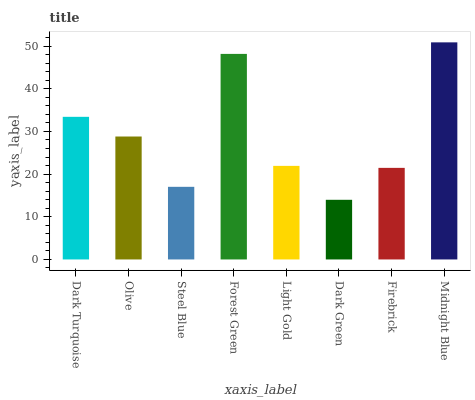Is Dark Green the minimum?
Answer yes or no. Yes. Is Midnight Blue the maximum?
Answer yes or no. Yes. Is Olive the minimum?
Answer yes or no. No. Is Olive the maximum?
Answer yes or no. No. Is Dark Turquoise greater than Olive?
Answer yes or no. Yes. Is Olive less than Dark Turquoise?
Answer yes or no. Yes. Is Olive greater than Dark Turquoise?
Answer yes or no. No. Is Dark Turquoise less than Olive?
Answer yes or no. No. Is Olive the high median?
Answer yes or no. Yes. Is Light Gold the low median?
Answer yes or no. Yes. Is Dark Green the high median?
Answer yes or no. No. Is Olive the low median?
Answer yes or no. No. 